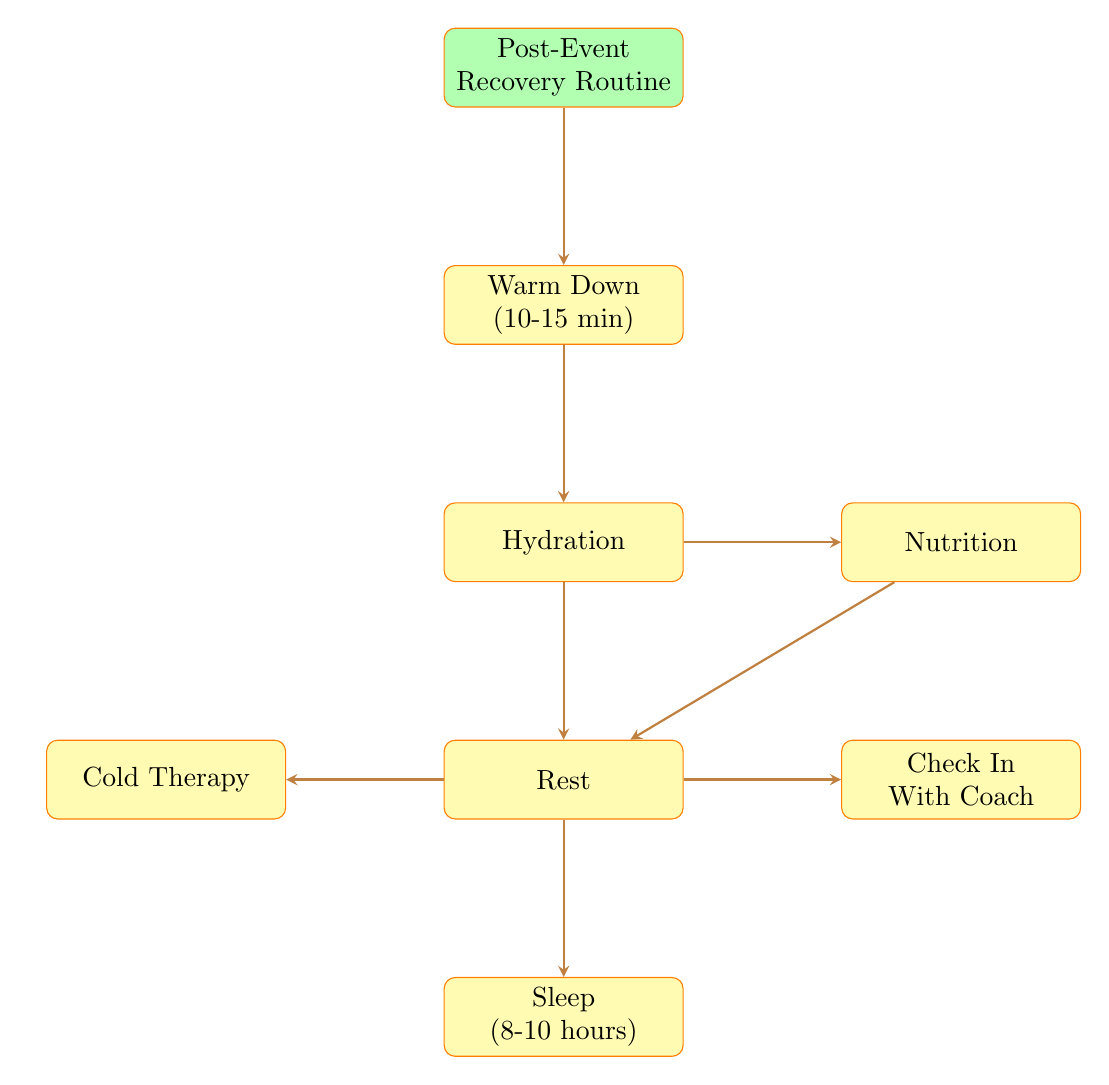What is the first step in the Post-Event Recovery Routine? The diagram shows that "Warm Down" is the first step listed under the "Post-Event Recovery Routine".
Answer: Warm Down How long should the Warm Down last? The diagram specifies that the duration for the "Warm Down" step is "10-15 minutes".
Answer: 10-15 minutes What is recommended for hydration? Looking at the "Hydration" node, the diagram lists "Water", "Coconut water", and "Sports drinks" as recommended drinks.
Answer: Water, Coconut water, Sports drinks Which nodes are directly connected to the "Rest" node? The diagram indicates that the "Rest" node has three arrows pointing to "Cold Therapy", "Check In With Coach", and "Sleep", meaning these are directly connected.
Answer: Cold Therapy, Check In With Coach, Sleep What is the recommended sleep duration? The "Sleep" node provides the recommended duration as "8-10 hours".
Answer: 8-10 hours What two activities are suggested for rest? The "Rest" node lists suggestions like "Napping", "Light reading", and "Listening to music". However, the question asks for two, so we can pick any two from these suggested activities.
Answer: Napping, Light reading What step follows Hydration in the flow? The flow chart shows that "Nutrition" comes immediately after "Hydration".
Answer: Nutrition How does the Cold Therapy connect to other nodes? The "Cold Therapy" node is connected to the "Rest" node only, meaning it should be performed after resting.
Answer: Rest What do you discuss when you check in with your coach? The diagram specifies that topics to discuss include "Performance review", "Recovery plan", and "Next event preparation".
Answer: Performance review, Recovery plan, Next event preparation 